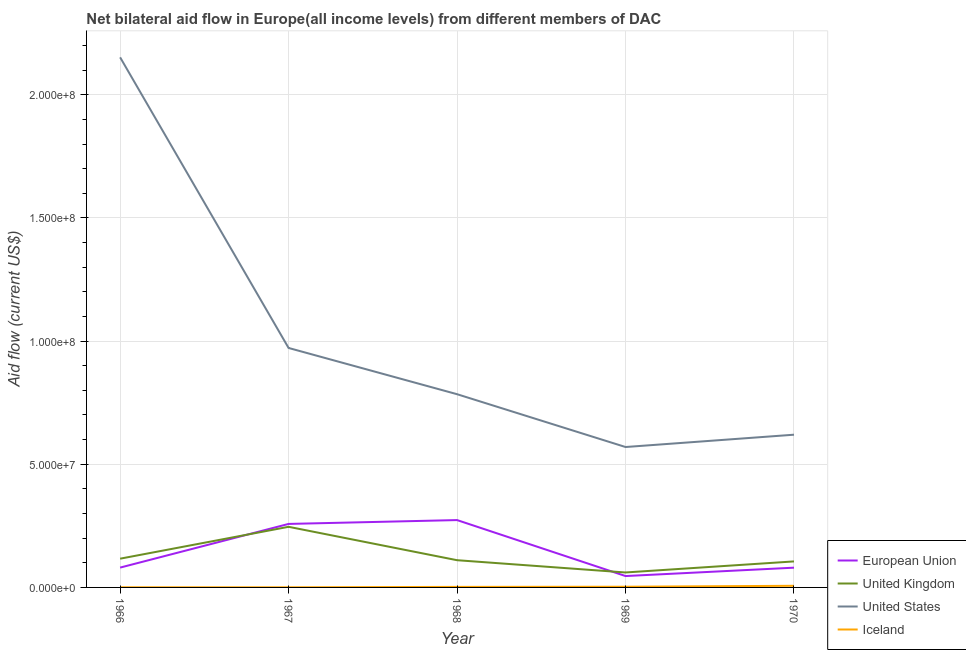How many different coloured lines are there?
Ensure brevity in your answer.  4. Is the number of lines equal to the number of legend labels?
Give a very brief answer. Yes. What is the amount of aid given by eu in 1966?
Ensure brevity in your answer.  8.05e+06. Across all years, what is the maximum amount of aid given by iceland?
Make the answer very short. 6.60e+05. Across all years, what is the minimum amount of aid given by eu?
Provide a succinct answer. 4.62e+06. In which year was the amount of aid given by eu maximum?
Keep it short and to the point. 1968. In which year was the amount of aid given by iceland minimum?
Ensure brevity in your answer.  1967. What is the total amount of aid given by iceland in the graph?
Give a very brief answer. 1.27e+06. What is the difference between the amount of aid given by eu in 1967 and that in 1970?
Your answer should be compact. 1.78e+07. What is the difference between the amount of aid given by us in 1967 and the amount of aid given by uk in 1969?
Your answer should be very brief. 9.11e+07. What is the average amount of aid given by uk per year?
Your answer should be very brief. 1.28e+07. In the year 1966, what is the difference between the amount of aid given by eu and amount of aid given by iceland?
Provide a succinct answer. 7.99e+06. In how many years, is the amount of aid given by us greater than 210000000 US$?
Give a very brief answer. 1. What is the ratio of the amount of aid given by iceland in 1968 to that in 1969?
Give a very brief answer. 0.79. Is the amount of aid given by iceland in 1967 less than that in 1969?
Provide a succinct answer. Yes. What is the difference between the highest and the second highest amount of aid given by iceland?
Your response must be concise. 3.80e+05. What is the difference between the highest and the lowest amount of aid given by uk?
Offer a terse response. 1.85e+07. In how many years, is the amount of aid given by iceland greater than the average amount of aid given by iceland taken over all years?
Offer a very short reply. 2. Is it the case that in every year, the sum of the amount of aid given by us and amount of aid given by iceland is greater than the sum of amount of aid given by uk and amount of aid given by eu?
Keep it short and to the point. Yes. Is it the case that in every year, the sum of the amount of aid given by eu and amount of aid given by uk is greater than the amount of aid given by us?
Give a very brief answer. No. Does the amount of aid given by iceland monotonically increase over the years?
Provide a succinct answer. No. Is the amount of aid given by iceland strictly greater than the amount of aid given by uk over the years?
Provide a short and direct response. No. Is the amount of aid given by iceland strictly less than the amount of aid given by uk over the years?
Your answer should be very brief. Yes. How many lines are there?
Your response must be concise. 4. How many years are there in the graph?
Offer a terse response. 5. Are the values on the major ticks of Y-axis written in scientific E-notation?
Your response must be concise. Yes. Does the graph contain any zero values?
Offer a very short reply. No. Does the graph contain grids?
Your answer should be very brief. Yes. Where does the legend appear in the graph?
Provide a short and direct response. Bottom right. How many legend labels are there?
Your answer should be very brief. 4. What is the title of the graph?
Offer a very short reply. Net bilateral aid flow in Europe(all income levels) from different members of DAC. What is the label or title of the X-axis?
Ensure brevity in your answer.  Year. What is the label or title of the Y-axis?
Offer a terse response. Aid flow (current US$). What is the Aid flow (current US$) of European Union in 1966?
Your answer should be compact. 8.05e+06. What is the Aid flow (current US$) of United Kingdom in 1966?
Your response must be concise. 1.17e+07. What is the Aid flow (current US$) of United States in 1966?
Make the answer very short. 2.15e+08. What is the Aid flow (current US$) of European Union in 1967?
Offer a very short reply. 2.58e+07. What is the Aid flow (current US$) of United Kingdom in 1967?
Offer a terse response. 2.46e+07. What is the Aid flow (current US$) of United States in 1967?
Offer a very short reply. 9.72e+07. What is the Aid flow (current US$) in Iceland in 1967?
Your answer should be compact. 5.00e+04. What is the Aid flow (current US$) in European Union in 1968?
Your answer should be compact. 2.73e+07. What is the Aid flow (current US$) in United Kingdom in 1968?
Offer a terse response. 1.10e+07. What is the Aid flow (current US$) in United States in 1968?
Offer a terse response. 7.84e+07. What is the Aid flow (current US$) in European Union in 1969?
Ensure brevity in your answer.  4.62e+06. What is the Aid flow (current US$) in United Kingdom in 1969?
Your answer should be compact. 6.07e+06. What is the Aid flow (current US$) of United States in 1969?
Your answer should be compact. 5.70e+07. What is the Aid flow (current US$) in Iceland in 1969?
Ensure brevity in your answer.  2.80e+05. What is the Aid flow (current US$) in European Union in 1970?
Your answer should be very brief. 8.02e+06. What is the Aid flow (current US$) in United Kingdom in 1970?
Offer a terse response. 1.06e+07. What is the Aid flow (current US$) in United States in 1970?
Provide a succinct answer. 6.20e+07. What is the Aid flow (current US$) of Iceland in 1970?
Your response must be concise. 6.60e+05. Across all years, what is the maximum Aid flow (current US$) in European Union?
Your answer should be compact. 2.73e+07. Across all years, what is the maximum Aid flow (current US$) in United Kingdom?
Offer a terse response. 2.46e+07. Across all years, what is the maximum Aid flow (current US$) of United States?
Offer a very short reply. 2.15e+08. Across all years, what is the minimum Aid flow (current US$) in European Union?
Provide a succinct answer. 4.62e+06. Across all years, what is the minimum Aid flow (current US$) in United Kingdom?
Your answer should be compact. 6.07e+06. Across all years, what is the minimum Aid flow (current US$) of United States?
Your response must be concise. 5.70e+07. Across all years, what is the minimum Aid flow (current US$) of Iceland?
Keep it short and to the point. 5.00e+04. What is the total Aid flow (current US$) in European Union in the graph?
Your answer should be very brief. 7.38e+07. What is the total Aid flow (current US$) in United Kingdom in the graph?
Ensure brevity in your answer.  6.40e+07. What is the total Aid flow (current US$) of United States in the graph?
Offer a terse response. 5.10e+08. What is the total Aid flow (current US$) in Iceland in the graph?
Your answer should be very brief. 1.27e+06. What is the difference between the Aid flow (current US$) of European Union in 1966 and that in 1967?
Make the answer very short. -1.77e+07. What is the difference between the Aid flow (current US$) of United Kingdom in 1966 and that in 1967?
Make the answer very short. -1.29e+07. What is the difference between the Aid flow (current US$) in United States in 1966 and that in 1967?
Ensure brevity in your answer.  1.18e+08. What is the difference between the Aid flow (current US$) in European Union in 1966 and that in 1968?
Your answer should be very brief. -1.93e+07. What is the difference between the Aid flow (current US$) in United Kingdom in 1966 and that in 1968?
Keep it short and to the point. 6.20e+05. What is the difference between the Aid flow (current US$) of United States in 1966 and that in 1968?
Your response must be concise. 1.37e+08. What is the difference between the Aid flow (current US$) of Iceland in 1966 and that in 1968?
Ensure brevity in your answer.  -1.60e+05. What is the difference between the Aid flow (current US$) of European Union in 1966 and that in 1969?
Make the answer very short. 3.43e+06. What is the difference between the Aid flow (current US$) in United Kingdom in 1966 and that in 1969?
Make the answer very short. 5.60e+06. What is the difference between the Aid flow (current US$) in United States in 1966 and that in 1969?
Provide a succinct answer. 1.58e+08. What is the difference between the Aid flow (current US$) of United Kingdom in 1966 and that in 1970?
Keep it short and to the point. 1.11e+06. What is the difference between the Aid flow (current US$) in United States in 1966 and that in 1970?
Your answer should be compact. 1.53e+08. What is the difference between the Aid flow (current US$) in Iceland in 1966 and that in 1970?
Give a very brief answer. -6.00e+05. What is the difference between the Aid flow (current US$) of European Union in 1967 and that in 1968?
Offer a terse response. -1.56e+06. What is the difference between the Aid flow (current US$) of United Kingdom in 1967 and that in 1968?
Ensure brevity in your answer.  1.36e+07. What is the difference between the Aid flow (current US$) of United States in 1967 and that in 1968?
Offer a very short reply. 1.88e+07. What is the difference between the Aid flow (current US$) in Iceland in 1967 and that in 1968?
Keep it short and to the point. -1.70e+05. What is the difference between the Aid flow (current US$) in European Union in 1967 and that in 1969?
Provide a succinct answer. 2.12e+07. What is the difference between the Aid flow (current US$) in United Kingdom in 1967 and that in 1969?
Offer a very short reply. 1.85e+07. What is the difference between the Aid flow (current US$) of United States in 1967 and that in 1969?
Make the answer very short. 4.02e+07. What is the difference between the Aid flow (current US$) of Iceland in 1967 and that in 1969?
Provide a succinct answer. -2.30e+05. What is the difference between the Aid flow (current US$) of European Union in 1967 and that in 1970?
Ensure brevity in your answer.  1.78e+07. What is the difference between the Aid flow (current US$) of United Kingdom in 1967 and that in 1970?
Provide a short and direct response. 1.40e+07. What is the difference between the Aid flow (current US$) in United States in 1967 and that in 1970?
Ensure brevity in your answer.  3.52e+07. What is the difference between the Aid flow (current US$) in Iceland in 1967 and that in 1970?
Your answer should be very brief. -6.10e+05. What is the difference between the Aid flow (current US$) in European Union in 1968 and that in 1969?
Give a very brief answer. 2.27e+07. What is the difference between the Aid flow (current US$) of United Kingdom in 1968 and that in 1969?
Keep it short and to the point. 4.98e+06. What is the difference between the Aid flow (current US$) in United States in 1968 and that in 1969?
Make the answer very short. 2.14e+07. What is the difference between the Aid flow (current US$) of European Union in 1968 and that in 1970?
Provide a succinct answer. 1.93e+07. What is the difference between the Aid flow (current US$) in United Kingdom in 1968 and that in 1970?
Provide a succinct answer. 4.90e+05. What is the difference between the Aid flow (current US$) of United States in 1968 and that in 1970?
Your answer should be compact. 1.64e+07. What is the difference between the Aid flow (current US$) of Iceland in 1968 and that in 1970?
Provide a short and direct response. -4.40e+05. What is the difference between the Aid flow (current US$) of European Union in 1969 and that in 1970?
Offer a terse response. -3.40e+06. What is the difference between the Aid flow (current US$) in United Kingdom in 1969 and that in 1970?
Your answer should be compact. -4.49e+06. What is the difference between the Aid flow (current US$) in United States in 1969 and that in 1970?
Keep it short and to the point. -5.00e+06. What is the difference between the Aid flow (current US$) of Iceland in 1969 and that in 1970?
Your answer should be compact. -3.80e+05. What is the difference between the Aid flow (current US$) in European Union in 1966 and the Aid flow (current US$) in United Kingdom in 1967?
Provide a succinct answer. -1.66e+07. What is the difference between the Aid flow (current US$) of European Union in 1966 and the Aid flow (current US$) of United States in 1967?
Your response must be concise. -8.92e+07. What is the difference between the Aid flow (current US$) of United Kingdom in 1966 and the Aid flow (current US$) of United States in 1967?
Your answer should be very brief. -8.55e+07. What is the difference between the Aid flow (current US$) in United Kingdom in 1966 and the Aid flow (current US$) in Iceland in 1967?
Give a very brief answer. 1.16e+07. What is the difference between the Aid flow (current US$) of United States in 1966 and the Aid flow (current US$) of Iceland in 1967?
Ensure brevity in your answer.  2.15e+08. What is the difference between the Aid flow (current US$) of European Union in 1966 and the Aid flow (current US$) of United Kingdom in 1968?
Offer a very short reply. -3.00e+06. What is the difference between the Aid flow (current US$) in European Union in 1966 and the Aid flow (current US$) in United States in 1968?
Provide a succinct answer. -7.04e+07. What is the difference between the Aid flow (current US$) of European Union in 1966 and the Aid flow (current US$) of Iceland in 1968?
Ensure brevity in your answer.  7.83e+06. What is the difference between the Aid flow (current US$) in United Kingdom in 1966 and the Aid flow (current US$) in United States in 1968?
Offer a very short reply. -6.68e+07. What is the difference between the Aid flow (current US$) of United Kingdom in 1966 and the Aid flow (current US$) of Iceland in 1968?
Ensure brevity in your answer.  1.14e+07. What is the difference between the Aid flow (current US$) of United States in 1966 and the Aid flow (current US$) of Iceland in 1968?
Offer a terse response. 2.15e+08. What is the difference between the Aid flow (current US$) of European Union in 1966 and the Aid flow (current US$) of United Kingdom in 1969?
Ensure brevity in your answer.  1.98e+06. What is the difference between the Aid flow (current US$) in European Union in 1966 and the Aid flow (current US$) in United States in 1969?
Your answer should be very brief. -4.90e+07. What is the difference between the Aid flow (current US$) in European Union in 1966 and the Aid flow (current US$) in Iceland in 1969?
Provide a short and direct response. 7.77e+06. What is the difference between the Aid flow (current US$) of United Kingdom in 1966 and the Aid flow (current US$) of United States in 1969?
Keep it short and to the point. -4.53e+07. What is the difference between the Aid flow (current US$) of United Kingdom in 1966 and the Aid flow (current US$) of Iceland in 1969?
Your answer should be very brief. 1.14e+07. What is the difference between the Aid flow (current US$) of United States in 1966 and the Aid flow (current US$) of Iceland in 1969?
Offer a very short reply. 2.15e+08. What is the difference between the Aid flow (current US$) in European Union in 1966 and the Aid flow (current US$) in United Kingdom in 1970?
Offer a very short reply. -2.51e+06. What is the difference between the Aid flow (current US$) of European Union in 1966 and the Aid flow (current US$) of United States in 1970?
Ensure brevity in your answer.  -5.40e+07. What is the difference between the Aid flow (current US$) in European Union in 1966 and the Aid flow (current US$) in Iceland in 1970?
Offer a very short reply. 7.39e+06. What is the difference between the Aid flow (current US$) in United Kingdom in 1966 and the Aid flow (current US$) in United States in 1970?
Your answer should be very brief. -5.03e+07. What is the difference between the Aid flow (current US$) of United Kingdom in 1966 and the Aid flow (current US$) of Iceland in 1970?
Provide a short and direct response. 1.10e+07. What is the difference between the Aid flow (current US$) in United States in 1966 and the Aid flow (current US$) in Iceland in 1970?
Your response must be concise. 2.15e+08. What is the difference between the Aid flow (current US$) of European Union in 1967 and the Aid flow (current US$) of United Kingdom in 1968?
Offer a very short reply. 1.47e+07. What is the difference between the Aid flow (current US$) of European Union in 1967 and the Aid flow (current US$) of United States in 1968?
Make the answer very short. -5.27e+07. What is the difference between the Aid flow (current US$) in European Union in 1967 and the Aid flow (current US$) in Iceland in 1968?
Offer a very short reply. 2.56e+07. What is the difference between the Aid flow (current US$) of United Kingdom in 1967 and the Aid flow (current US$) of United States in 1968?
Your response must be concise. -5.38e+07. What is the difference between the Aid flow (current US$) of United Kingdom in 1967 and the Aid flow (current US$) of Iceland in 1968?
Make the answer very short. 2.44e+07. What is the difference between the Aid flow (current US$) of United States in 1967 and the Aid flow (current US$) of Iceland in 1968?
Provide a succinct answer. 9.70e+07. What is the difference between the Aid flow (current US$) of European Union in 1967 and the Aid flow (current US$) of United Kingdom in 1969?
Your response must be concise. 1.97e+07. What is the difference between the Aid flow (current US$) of European Union in 1967 and the Aid flow (current US$) of United States in 1969?
Your response must be concise. -3.12e+07. What is the difference between the Aid flow (current US$) of European Union in 1967 and the Aid flow (current US$) of Iceland in 1969?
Your answer should be compact. 2.55e+07. What is the difference between the Aid flow (current US$) in United Kingdom in 1967 and the Aid flow (current US$) in United States in 1969?
Your answer should be compact. -3.24e+07. What is the difference between the Aid flow (current US$) in United Kingdom in 1967 and the Aid flow (current US$) in Iceland in 1969?
Ensure brevity in your answer.  2.43e+07. What is the difference between the Aid flow (current US$) in United States in 1967 and the Aid flow (current US$) in Iceland in 1969?
Offer a very short reply. 9.69e+07. What is the difference between the Aid flow (current US$) in European Union in 1967 and the Aid flow (current US$) in United Kingdom in 1970?
Provide a succinct answer. 1.52e+07. What is the difference between the Aid flow (current US$) of European Union in 1967 and the Aid flow (current US$) of United States in 1970?
Offer a terse response. -3.62e+07. What is the difference between the Aid flow (current US$) of European Union in 1967 and the Aid flow (current US$) of Iceland in 1970?
Keep it short and to the point. 2.51e+07. What is the difference between the Aid flow (current US$) of United Kingdom in 1967 and the Aid flow (current US$) of United States in 1970?
Offer a terse response. -3.74e+07. What is the difference between the Aid flow (current US$) of United Kingdom in 1967 and the Aid flow (current US$) of Iceland in 1970?
Give a very brief answer. 2.40e+07. What is the difference between the Aid flow (current US$) of United States in 1967 and the Aid flow (current US$) of Iceland in 1970?
Offer a very short reply. 9.66e+07. What is the difference between the Aid flow (current US$) of European Union in 1968 and the Aid flow (current US$) of United Kingdom in 1969?
Provide a succinct answer. 2.13e+07. What is the difference between the Aid flow (current US$) of European Union in 1968 and the Aid flow (current US$) of United States in 1969?
Keep it short and to the point. -2.97e+07. What is the difference between the Aid flow (current US$) of European Union in 1968 and the Aid flow (current US$) of Iceland in 1969?
Provide a succinct answer. 2.71e+07. What is the difference between the Aid flow (current US$) of United Kingdom in 1968 and the Aid flow (current US$) of United States in 1969?
Provide a short and direct response. -4.60e+07. What is the difference between the Aid flow (current US$) in United Kingdom in 1968 and the Aid flow (current US$) in Iceland in 1969?
Offer a very short reply. 1.08e+07. What is the difference between the Aid flow (current US$) in United States in 1968 and the Aid flow (current US$) in Iceland in 1969?
Offer a terse response. 7.82e+07. What is the difference between the Aid flow (current US$) of European Union in 1968 and the Aid flow (current US$) of United Kingdom in 1970?
Your answer should be compact. 1.68e+07. What is the difference between the Aid flow (current US$) of European Union in 1968 and the Aid flow (current US$) of United States in 1970?
Keep it short and to the point. -3.47e+07. What is the difference between the Aid flow (current US$) in European Union in 1968 and the Aid flow (current US$) in Iceland in 1970?
Offer a terse response. 2.67e+07. What is the difference between the Aid flow (current US$) in United Kingdom in 1968 and the Aid flow (current US$) in United States in 1970?
Offer a very short reply. -5.10e+07. What is the difference between the Aid flow (current US$) in United Kingdom in 1968 and the Aid flow (current US$) in Iceland in 1970?
Offer a very short reply. 1.04e+07. What is the difference between the Aid flow (current US$) in United States in 1968 and the Aid flow (current US$) in Iceland in 1970?
Provide a succinct answer. 7.78e+07. What is the difference between the Aid flow (current US$) in European Union in 1969 and the Aid flow (current US$) in United Kingdom in 1970?
Your answer should be compact. -5.94e+06. What is the difference between the Aid flow (current US$) in European Union in 1969 and the Aid flow (current US$) in United States in 1970?
Give a very brief answer. -5.74e+07. What is the difference between the Aid flow (current US$) of European Union in 1969 and the Aid flow (current US$) of Iceland in 1970?
Your answer should be compact. 3.96e+06. What is the difference between the Aid flow (current US$) in United Kingdom in 1969 and the Aid flow (current US$) in United States in 1970?
Offer a terse response. -5.59e+07. What is the difference between the Aid flow (current US$) in United Kingdom in 1969 and the Aid flow (current US$) in Iceland in 1970?
Provide a short and direct response. 5.41e+06. What is the difference between the Aid flow (current US$) of United States in 1969 and the Aid flow (current US$) of Iceland in 1970?
Give a very brief answer. 5.63e+07. What is the average Aid flow (current US$) of European Union per year?
Keep it short and to the point. 1.48e+07. What is the average Aid flow (current US$) of United Kingdom per year?
Make the answer very short. 1.28e+07. What is the average Aid flow (current US$) in United States per year?
Give a very brief answer. 1.02e+08. What is the average Aid flow (current US$) in Iceland per year?
Provide a succinct answer. 2.54e+05. In the year 1966, what is the difference between the Aid flow (current US$) of European Union and Aid flow (current US$) of United Kingdom?
Your answer should be very brief. -3.62e+06. In the year 1966, what is the difference between the Aid flow (current US$) of European Union and Aid flow (current US$) of United States?
Ensure brevity in your answer.  -2.07e+08. In the year 1966, what is the difference between the Aid flow (current US$) of European Union and Aid flow (current US$) of Iceland?
Your answer should be compact. 7.99e+06. In the year 1966, what is the difference between the Aid flow (current US$) in United Kingdom and Aid flow (current US$) in United States?
Offer a terse response. -2.04e+08. In the year 1966, what is the difference between the Aid flow (current US$) of United Kingdom and Aid flow (current US$) of Iceland?
Your answer should be compact. 1.16e+07. In the year 1966, what is the difference between the Aid flow (current US$) of United States and Aid flow (current US$) of Iceland?
Your answer should be very brief. 2.15e+08. In the year 1967, what is the difference between the Aid flow (current US$) of European Union and Aid flow (current US$) of United Kingdom?
Offer a terse response. 1.17e+06. In the year 1967, what is the difference between the Aid flow (current US$) in European Union and Aid flow (current US$) in United States?
Your answer should be compact. -7.14e+07. In the year 1967, what is the difference between the Aid flow (current US$) in European Union and Aid flow (current US$) in Iceland?
Ensure brevity in your answer.  2.57e+07. In the year 1967, what is the difference between the Aid flow (current US$) of United Kingdom and Aid flow (current US$) of United States?
Your answer should be compact. -7.26e+07. In the year 1967, what is the difference between the Aid flow (current US$) in United Kingdom and Aid flow (current US$) in Iceland?
Offer a terse response. 2.46e+07. In the year 1967, what is the difference between the Aid flow (current US$) of United States and Aid flow (current US$) of Iceland?
Your answer should be very brief. 9.72e+07. In the year 1968, what is the difference between the Aid flow (current US$) in European Union and Aid flow (current US$) in United Kingdom?
Offer a very short reply. 1.63e+07. In the year 1968, what is the difference between the Aid flow (current US$) in European Union and Aid flow (current US$) in United States?
Offer a terse response. -5.11e+07. In the year 1968, what is the difference between the Aid flow (current US$) in European Union and Aid flow (current US$) in Iceland?
Ensure brevity in your answer.  2.71e+07. In the year 1968, what is the difference between the Aid flow (current US$) in United Kingdom and Aid flow (current US$) in United States?
Your response must be concise. -6.74e+07. In the year 1968, what is the difference between the Aid flow (current US$) of United Kingdom and Aid flow (current US$) of Iceland?
Your response must be concise. 1.08e+07. In the year 1968, what is the difference between the Aid flow (current US$) of United States and Aid flow (current US$) of Iceland?
Provide a succinct answer. 7.82e+07. In the year 1969, what is the difference between the Aid flow (current US$) in European Union and Aid flow (current US$) in United Kingdom?
Your response must be concise. -1.45e+06. In the year 1969, what is the difference between the Aid flow (current US$) in European Union and Aid flow (current US$) in United States?
Ensure brevity in your answer.  -5.24e+07. In the year 1969, what is the difference between the Aid flow (current US$) of European Union and Aid flow (current US$) of Iceland?
Your response must be concise. 4.34e+06. In the year 1969, what is the difference between the Aid flow (current US$) in United Kingdom and Aid flow (current US$) in United States?
Offer a very short reply. -5.09e+07. In the year 1969, what is the difference between the Aid flow (current US$) of United Kingdom and Aid flow (current US$) of Iceland?
Offer a very short reply. 5.79e+06. In the year 1969, what is the difference between the Aid flow (current US$) of United States and Aid flow (current US$) of Iceland?
Your answer should be compact. 5.67e+07. In the year 1970, what is the difference between the Aid flow (current US$) in European Union and Aid flow (current US$) in United Kingdom?
Your answer should be compact. -2.54e+06. In the year 1970, what is the difference between the Aid flow (current US$) in European Union and Aid flow (current US$) in United States?
Keep it short and to the point. -5.40e+07. In the year 1970, what is the difference between the Aid flow (current US$) of European Union and Aid flow (current US$) of Iceland?
Make the answer very short. 7.36e+06. In the year 1970, what is the difference between the Aid flow (current US$) of United Kingdom and Aid flow (current US$) of United States?
Your answer should be very brief. -5.14e+07. In the year 1970, what is the difference between the Aid flow (current US$) of United Kingdom and Aid flow (current US$) of Iceland?
Offer a very short reply. 9.90e+06. In the year 1970, what is the difference between the Aid flow (current US$) of United States and Aid flow (current US$) of Iceland?
Make the answer very short. 6.13e+07. What is the ratio of the Aid flow (current US$) of European Union in 1966 to that in 1967?
Keep it short and to the point. 0.31. What is the ratio of the Aid flow (current US$) in United Kingdom in 1966 to that in 1967?
Provide a succinct answer. 0.47. What is the ratio of the Aid flow (current US$) in United States in 1966 to that in 1967?
Your answer should be very brief. 2.21. What is the ratio of the Aid flow (current US$) of European Union in 1966 to that in 1968?
Provide a succinct answer. 0.29. What is the ratio of the Aid flow (current US$) of United Kingdom in 1966 to that in 1968?
Your response must be concise. 1.06. What is the ratio of the Aid flow (current US$) in United States in 1966 to that in 1968?
Provide a succinct answer. 2.74. What is the ratio of the Aid flow (current US$) in Iceland in 1966 to that in 1968?
Your answer should be compact. 0.27. What is the ratio of the Aid flow (current US$) of European Union in 1966 to that in 1969?
Your response must be concise. 1.74. What is the ratio of the Aid flow (current US$) of United Kingdom in 1966 to that in 1969?
Give a very brief answer. 1.92. What is the ratio of the Aid flow (current US$) of United States in 1966 to that in 1969?
Your answer should be very brief. 3.78. What is the ratio of the Aid flow (current US$) of Iceland in 1966 to that in 1969?
Your response must be concise. 0.21. What is the ratio of the Aid flow (current US$) in United Kingdom in 1966 to that in 1970?
Offer a terse response. 1.11. What is the ratio of the Aid flow (current US$) in United States in 1966 to that in 1970?
Make the answer very short. 3.47. What is the ratio of the Aid flow (current US$) in Iceland in 1966 to that in 1970?
Your response must be concise. 0.09. What is the ratio of the Aid flow (current US$) of European Union in 1967 to that in 1968?
Offer a very short reply. 0.94. What is the ratio of the Aid flow (current US$) of United Kingdom in 1967 to that in 1968?
Your answer should be very brief. 2.23. What is the ratio of the Aid flow (current US$) of United States in 1967 to that in 1968?
Ensure brevity in your answer.  1.24. What is the ratio of the Aid flow (current US$) of Iceland in 1967 to that in 1968?
Offer a terse response. 0.23. What is the ratio of the Aid flow (current US$) in European Union in 1967 to that in 1969?
Keep it short and to the point. 5.58. What is the ratio of the Aid flow (current US$) in United Kingdom in 1967 to that in 1969?
Keep it short and to the point. 4.05. What is the ratio of the Aid flow (current US$) in United States in 1967 to that in 1969?
Offer a very short reply. 1.71. What is the ratio of the Aid flow (current US$) of Iceland in 1967 to that in 1969?
Keep it short and to the point. 0.18. What is the ratio of the Aid flow (current US$) of European Union in 1967 to that in 1970?
Give a very brief answer. 3.21. What is the ratio of the Aid flow (current US$) in United Kingdom in 1967 to that in 1970?
Make the answer very short. 2.33. What is the ratio of the Aid flow (current US$) of United States in 1967 to that in 1970?
Keep it short and to the point. 1.57. What is the ratio of the Aid flow (current US$) in Iceland in 1967 to that in 1970?
Give a very brief answer. 0.08. What is the ratio of the Aid flow (current US$) of European Union in 1968 to that in 1969?
Offer a very short reply. 5.92. What is the ratio of the Aid flow (current US$) of United Kingdom in 1968 to that in 1969?
Your response must be concise. 1.82. What is the ratio of the Aid flow (current US$) in United States in 1968 to that in 1969?
Give a very brief answer. 1.38. What is the ratio of the Aid flow (current US$) in Iceland in 1968 to that in 1969?
Offer a terse response. 0.79. What is the ratio of the Aid flow (current US$) of European Union in 1968 to that in 1970?
Give a very brief answer. 3.41. What is the ratio of the Aid flow (current US$) in United Kingdom in 1968 to that in 1970?
Your response must be concise. 1.05. What is the ratio of the Aid flow (current US$) of United States in 1968 to that in 1970?
Make the answer very short. 1.27. What is the ratio of the Aid flow (current US$) in European Union in 1969 to that in 1970?
Your response must be concise. 0.58. What is the ratio of the Aid flow (current US$) of United Kingdom in 1969 to that in 1970?
Offer a terse response. 0.57. What is the ratio of the Aid flow (current US$) of United States in 1969 to that in 1970?
Make the answer very short. 0.92. What is the ratio of the Aid flow (current US$) of Iceland in 1969 to that in 1970?
Make the answer very short. 0.42. What is the difference between the highest and the second highest Aid flow (current US$) in European Union?
Give a very brief answer. 1.56e+06. What is the difference between the highest and the second highest Aid flow (current US$) in United Kingdom?
Ensure brevity in your answer.  1.29e+07. What is the difference between the highest and the second highest Aid flow (current US$) of United States?
Offer a terse response. 1.18e+08. What is the difference between the highest and the second highest Aid flow (current US$) in Iceland?
Offer a very short reply. 3.80e+05. What is the difference between the highest and the lowest Aid flow (current US$) in European Union?
Your answer should be very brief. 2.27e+07. What is the difference between the highest and the lowest Aid flow (current US$) of United Kingdom?
Your answer should be very brief. 1.85e+07. What is the difference between the highest and the lowest Aid flow (current US$) of United States?
Your response must be concise. 1.58e+08. What is the difference between the highest and the lowest Aid flow (current US$) of Iceland?
Your answer should be very brief. 6.10e+05. 